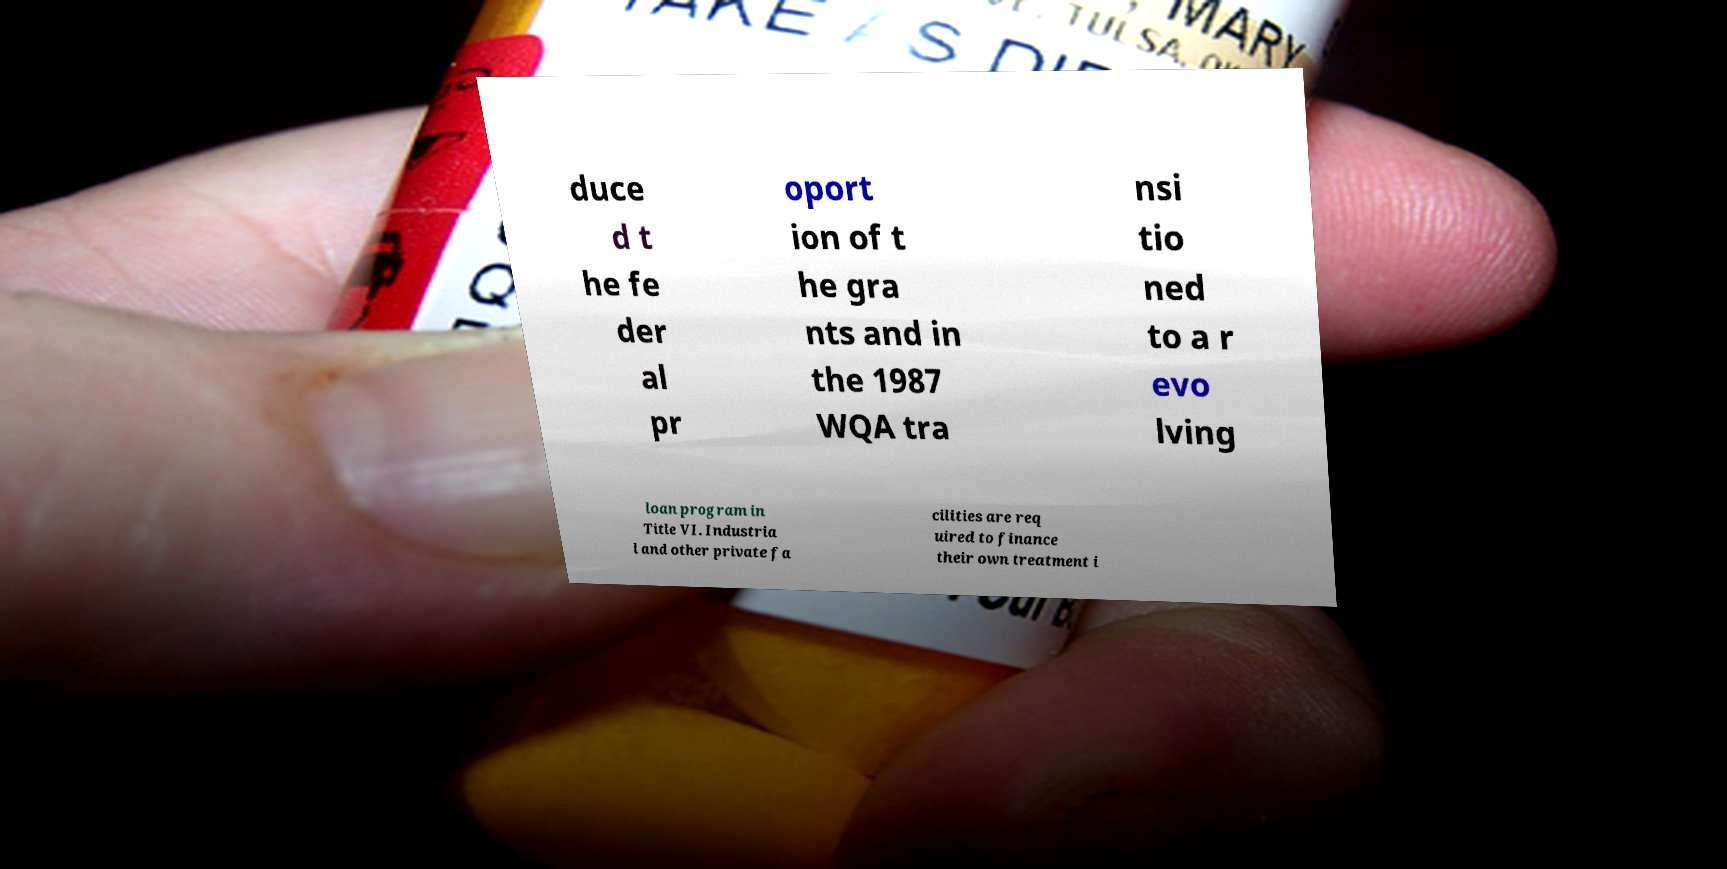Can you read and provide the text displayed in the image?This photo seems to have some interesting text. Can you extract and type it out for me? duce d t he fe der al pr oport ion of t he gra nts and in the 1987 WQA tra nsi tio ned to a r evo lving loan program in Title VI. Industria l and other private fa cilities are req uired to finance their own treatment i 